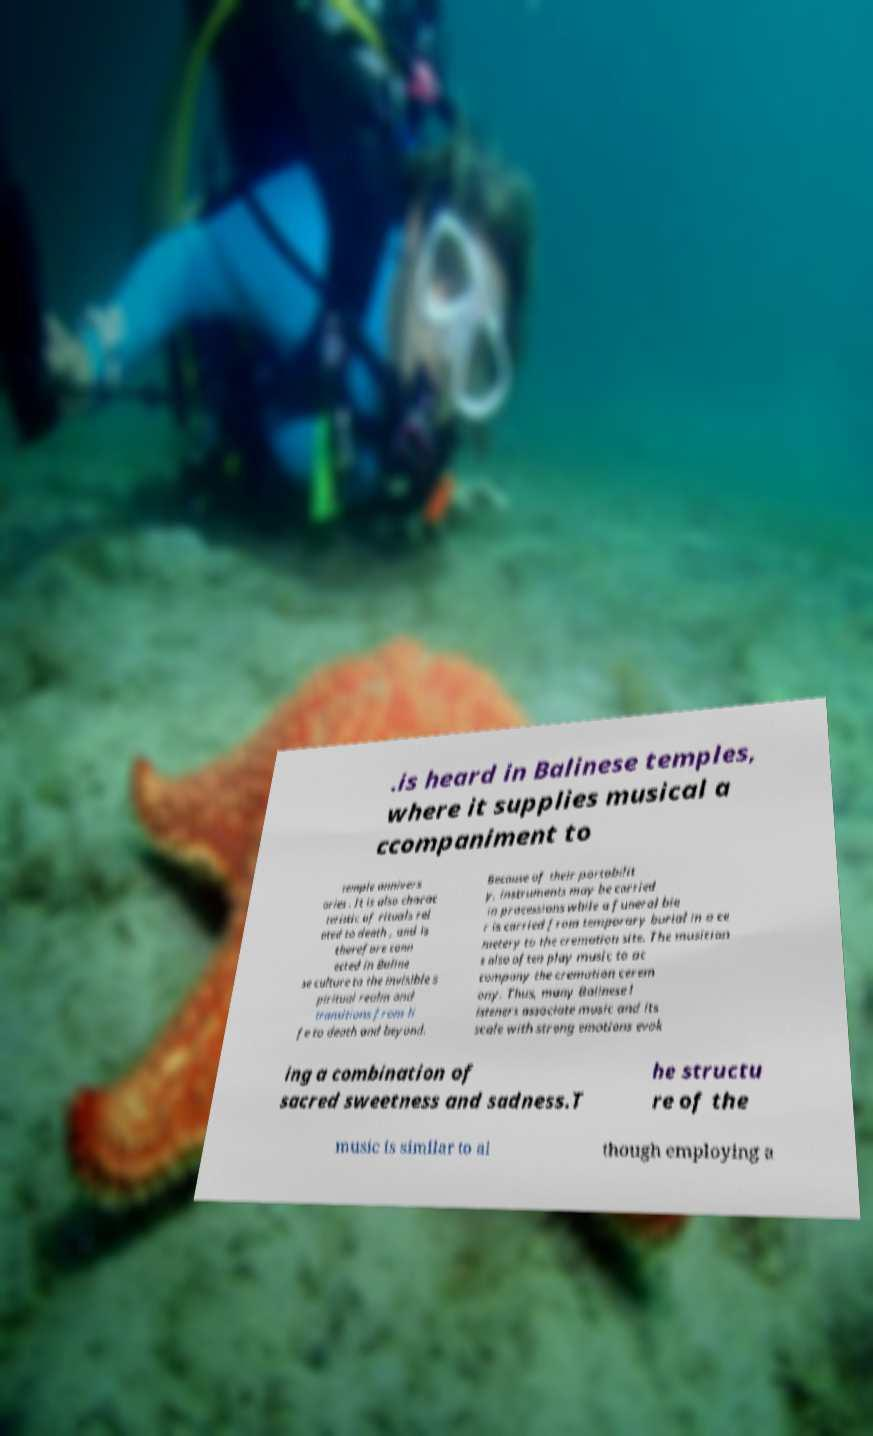Can you accurately transcribe the text from the provided image for me? .is heard in Balinese temples, where it supplies musical a ccompaniment to temple annivers aries . It is also charac teristic of rituals rel ated to death , and is therefore conn ected in Baline se culture to the invisible s piritual realm and transitions from li fe to death and beyond. Because of their portabilit y, instruments may be carried in processions while a funeral bie r is carried from temporary burial in a ce metery to the cremation site. The musician s also often play music to ac company the cremation cerem ony. Thus, many Balinese l isteners associate music and its scale with strong emotions evok ing a combination of sacred sweetness and sadness.T he structu re of the music is similar to al though employing a 